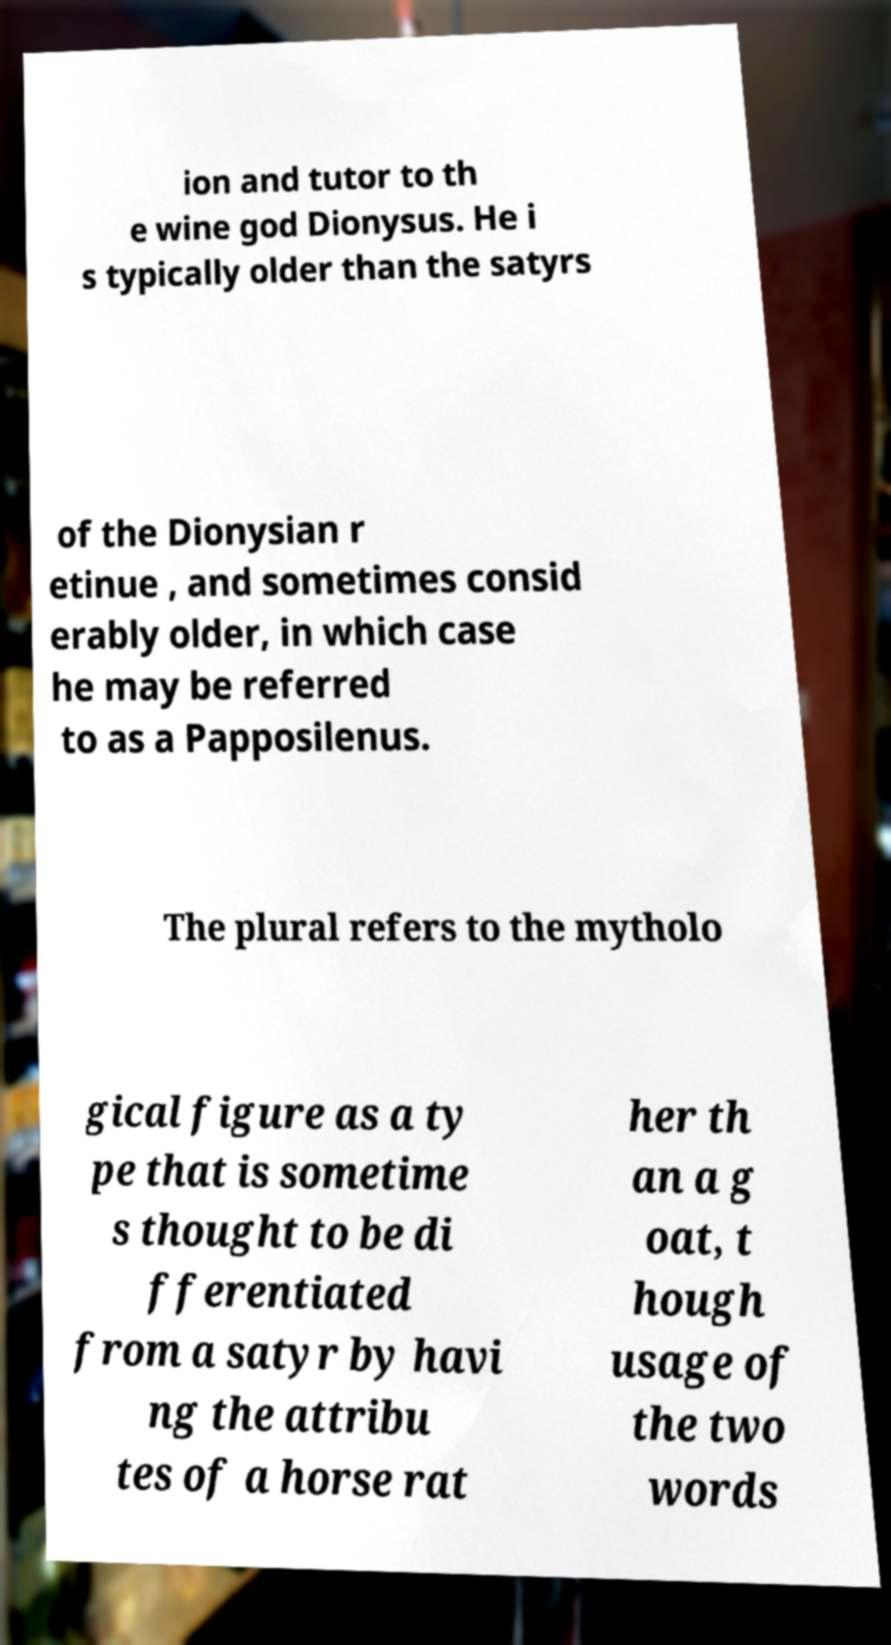What messages or text are displayed in this image? I need them in a readable, typed format. ion and tutor to th e wine god Dionysus. He i s typically older than the satyrs of the Dionysian r etinue , and sometimes consid erably older, in which case he may be referred to as a Papposilenus. The plural refers to the mytholo gical figure as a ty pe that is sometime s thought to be di fferentiated from a satyr by havi ng the attribu tes of a horse rat her th an a g oat, t hough usage of the two words 